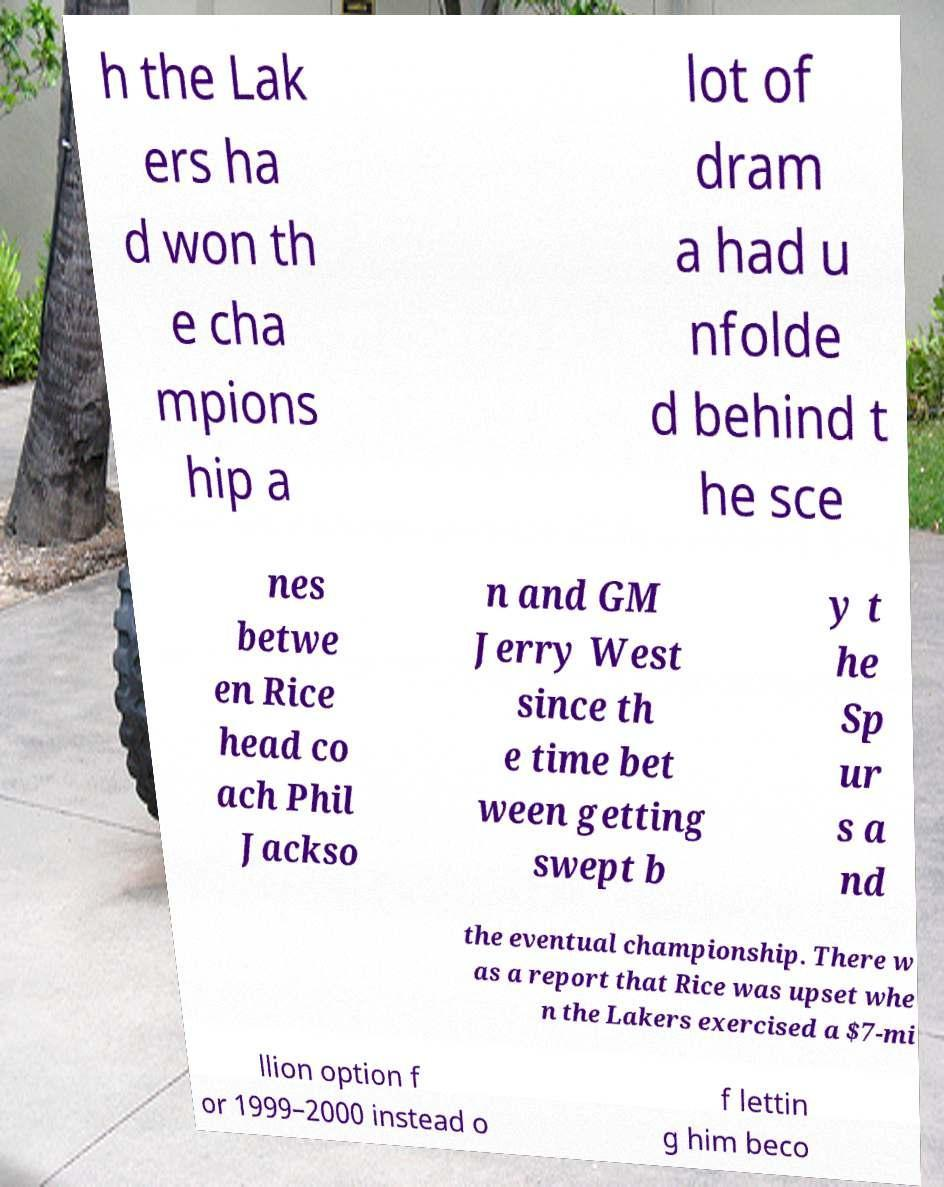Please identify and transcribe the text found in this image. h the Lak ers ha d won th e cha mpions hip a lot of dram a had u nfolde d behind t he sce nes betwe en Rice head co ach Phil Jackso n and GM Jerry West since th e time bet ween getting swept b y t he Sp ur s a nd the eventual championship. There w as a report that Rice was upset whe n the Lakers exercised a $7-mi llion option f or 1999–2000 instead o f lettin g him beco 